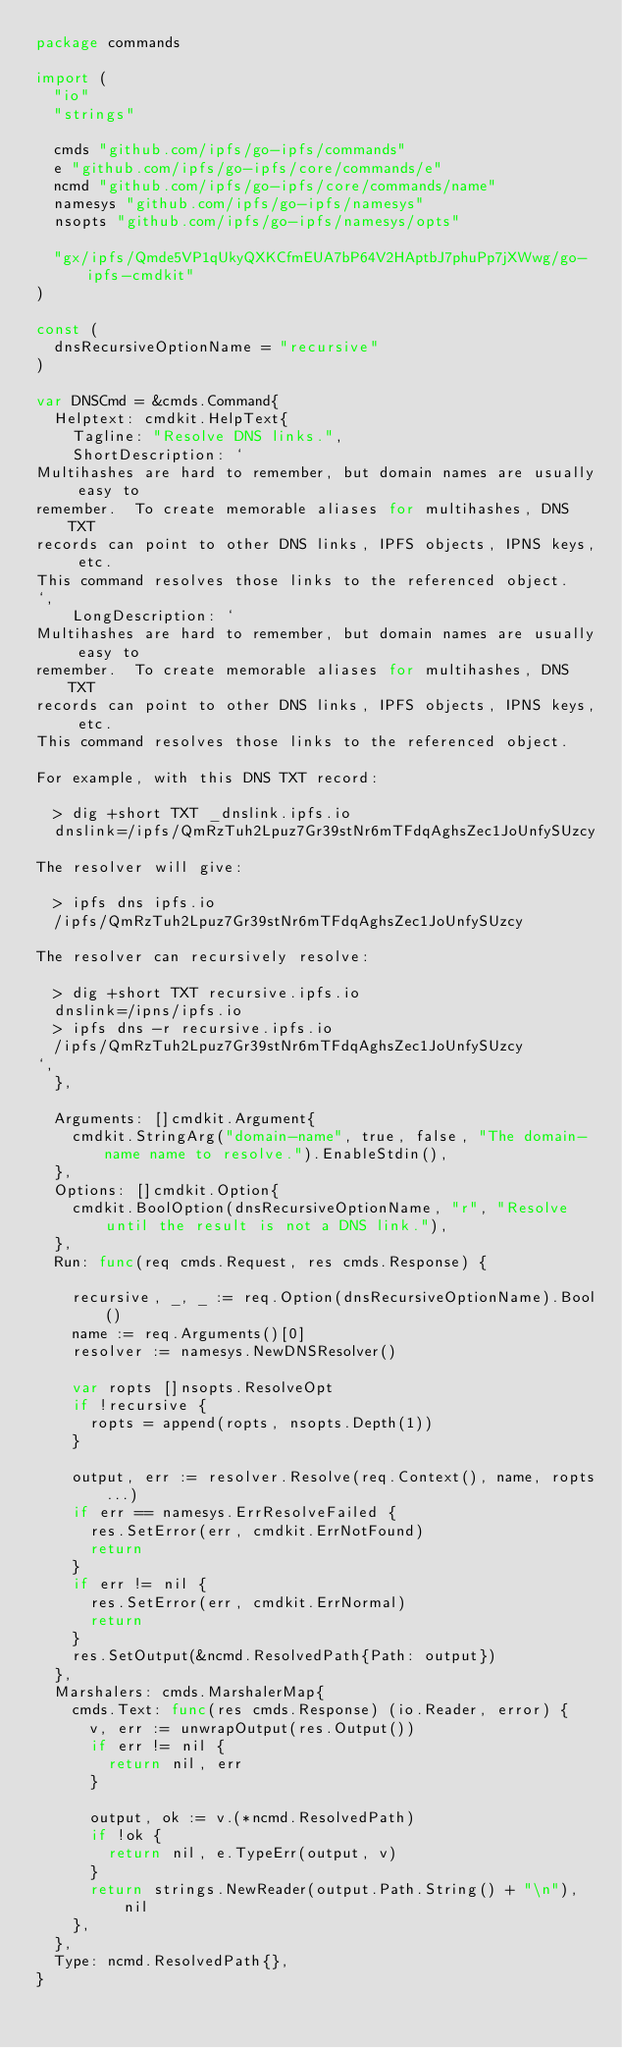<code> <loc_0><loc_0><loc_500><loc_500><_Go_>package commands

import (
	"io"
	"strings"

	cmds "github.com/ipfs/go-ipfs/commands"
	e "github.com/ipfs/go-ipfs/core/commands/e"
	ncmd "github.com/ipfs/go-ipfs/core/commands/name"
	namesys "github.com/ipfs/go-ipfs/namesys"
	nsopts "github.com/ipfs/go-ipfs/namesys/opts"

	"gx/ipfs/Qmde5VP1qUkyQXKCfmEUA7bP64V2HAptbJ7phuPp7jXWwg/go-ipfs-cmdkit"
)

const (
	dnsRecursiveOptionName = "recursive"
)

var DNSCmd = &cmds.Command{
	Helptext: cmdkit.HelpText{
		Tagline: "Resolve DNS links.",
		ShortDescription: `
Multihashes are hard to remember, but domain names are usually easy to
remember.  To create memorable aliases for multihashes, DNS TXT
records can point to other DNS links, IPFS objects, IPNS keys, etc.
This command resolves those links to the referenced object.
`,
		LongDescription: `
Multihashes are hard to remember, but domain names are usually easy to
remember.  To create memorable aliases for multihashes, DNS TXT
records can point to other DNS links, IPFS objects, IPNS keys, etc.
This command resolves those links to the referenced object.

For example, with this DNS TXT record:

	> dig +short TXT _dnslink.ipfs.io
	dnslink=/ipfs/QmRzTuh2Lpuz7Gr39stNr6mTFdqAghsZec1JoUnfySUzcy

The resolver will give:

	> ipfs dns ipfs.io
	/ipfs/QmRzTuh2Lpuz7Gr39stNr6mTFdqAghsZec1JoUnfySUzcy

The resolver can recursively resolve:

	> dig +short TXT recursive.ipfs.io
	dnslink=/ipns/ipfs.io
	> ipfs dns -r recursive.ipfs.io
	/ipfs/QmRzTuh2Lpuz7Gr39stNr6mTFdqAghsZec1JoUnfySUzcy
`,
	},

	Arguments: []cmdkit.Argument{
		cmdkit.StringArg("domain-name", true, false, "The domain-name name to resolve.").EnableStdin(),
	},
	Options: []cmdkit.Option{
		cmdkit.BoolOption(dnsRecursiveOptionName, "r", "Resolve until the result is not a DNS link."),
	},
	Run: func(req cmds.Request, res cmds.Response) {

		recursive, _, _ := req.Option(dnsRecursiveOptionName).Bool()
		name := req.Arguments()[0]
		resolver := namesys.NewDNSResolver()

		var ropts []nsopts.ResolveOpt
		if !recursive {
			ropts = append(ropts, nsopts.Depth(1))
		}

		output, err := resolver.Resolve(req.Context(), name, ropts...)
		if err == namesys.ErrResolveFailed {
			res.SetError(err, cmdkit.ErrNotFound)
			return
		}
		if err != nil {
			res.SetError(err, cmdkit.ErrNormal)
			return
		}
		res.SetOutput(&ncmd.ResolvedPath{Path: output})
	},
	Marshalers: cmds.MarshalerMap{
		cmds.Text: func(res cmds.Response) (io.Reader, error) {
			v, err := unwrapOutput(res.Output())
			if err != nil {
				return nil, err
			}

			output, ok := v.(*ncmd.ResolvedPath)
			if !ok {
				return nil, e.TypeErr(output, v)
			}
			return strings.NewReader(output.Path.String() + "\n"), nil
		},
	},
	Type: ncmd.ResolvedPath{},
}
</code> 